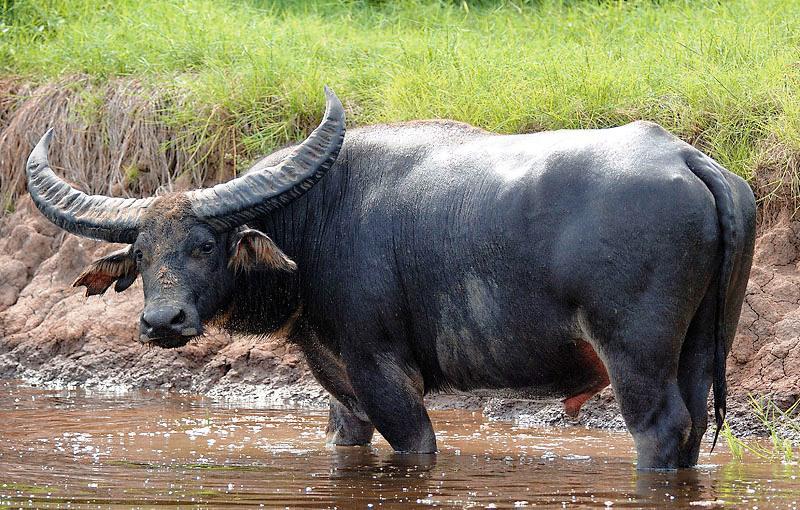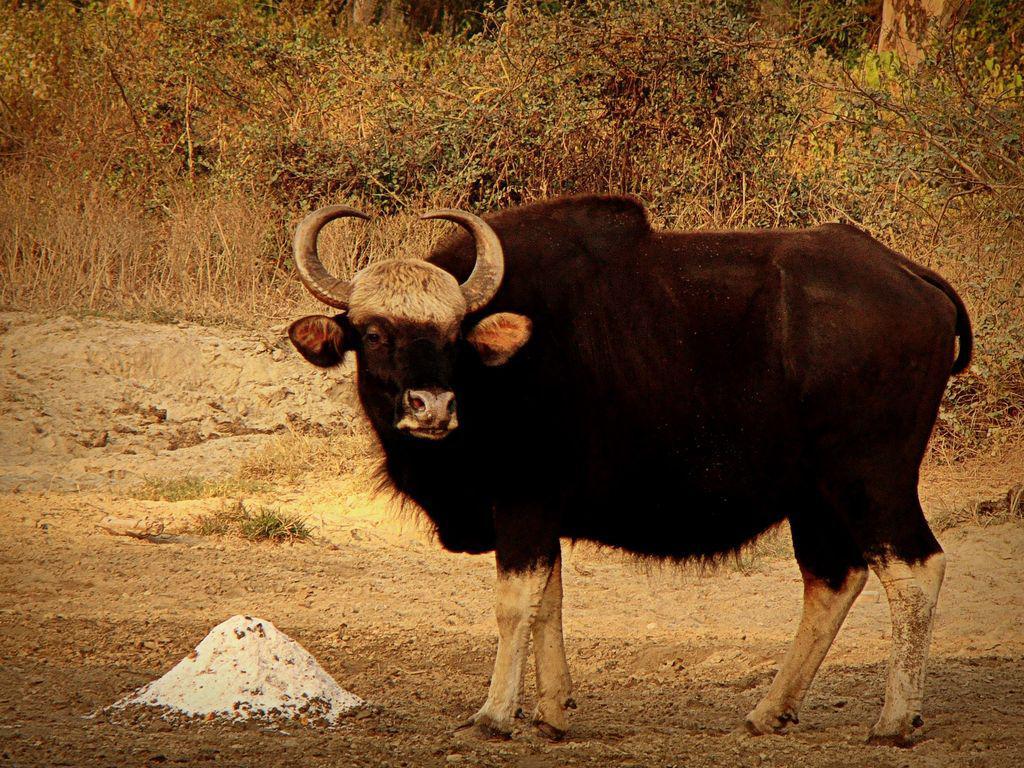The first image is the image on the left, the second image is the image on the right. Assess this claim about the two images: "Left image contains twice as many hooved animals as the right image.". Correct or not? Answer yes or no. No. The first image is the image on the left, the second image is the image on the right. Considering the images on both sides, is "The left image contains two water buffalo's." valid? Answer yes or no. No. 